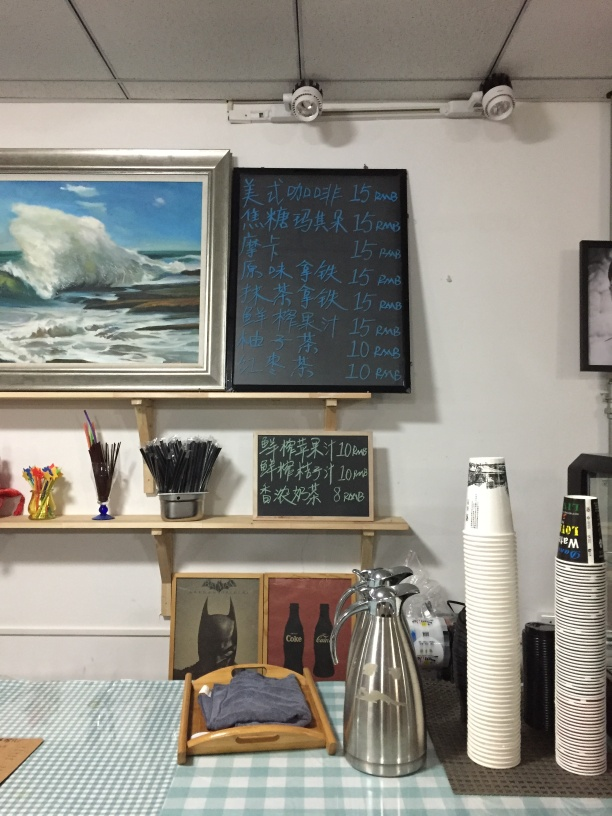Can you tell me what is written on the blackboard? The blackboard lists various drinks with their respective prices in RMB (Renminbi). It indicates that this place likely offers refreshments, common in a café or similar establishment. 